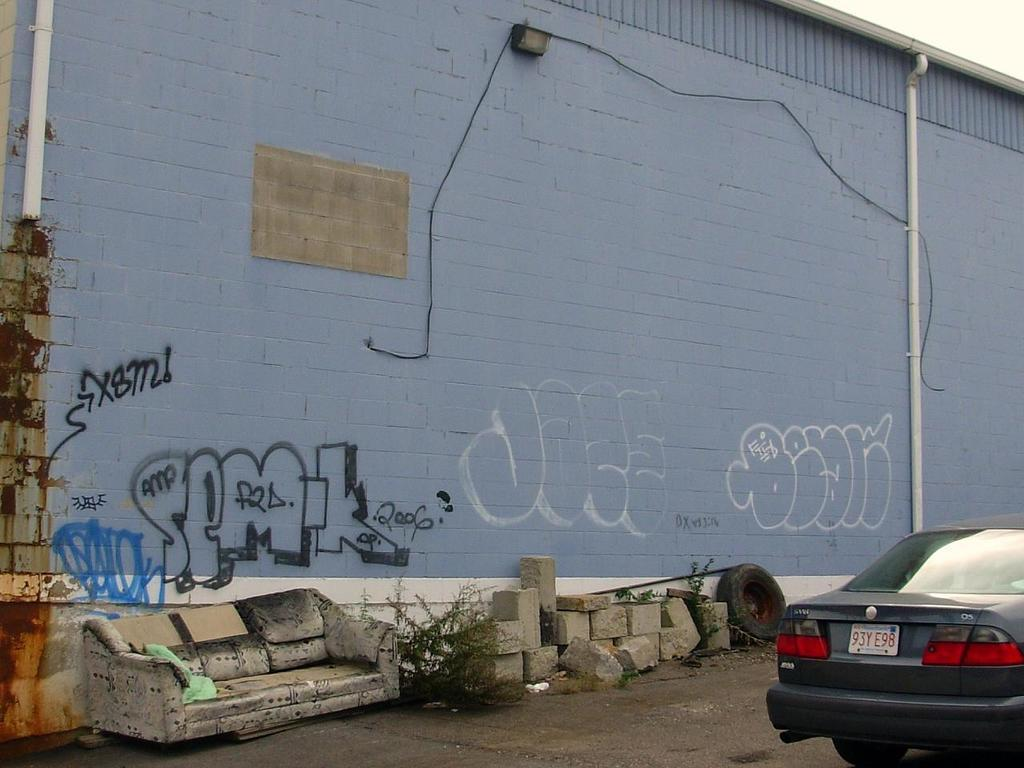What is the main subject of the image? The main subject of the image is a car on the road. What can be seen on the car? The car has a number plate. What other objects are present in the image? There is a damaged sofa, stones, grass, a pipe, cable wires, and a wall. What is the color of the sky in the image? The sky is white in the image. What time of day is it in the image, based on the hour? The provided facts do not mention the time of day or any specific hour, so it cannot be determined from the image. What type of alley is visible in the image? There is no alley present in the image; it features a car on the road, a damaged sofa, stones, grass, a pipe, cable wires, and a wall. 